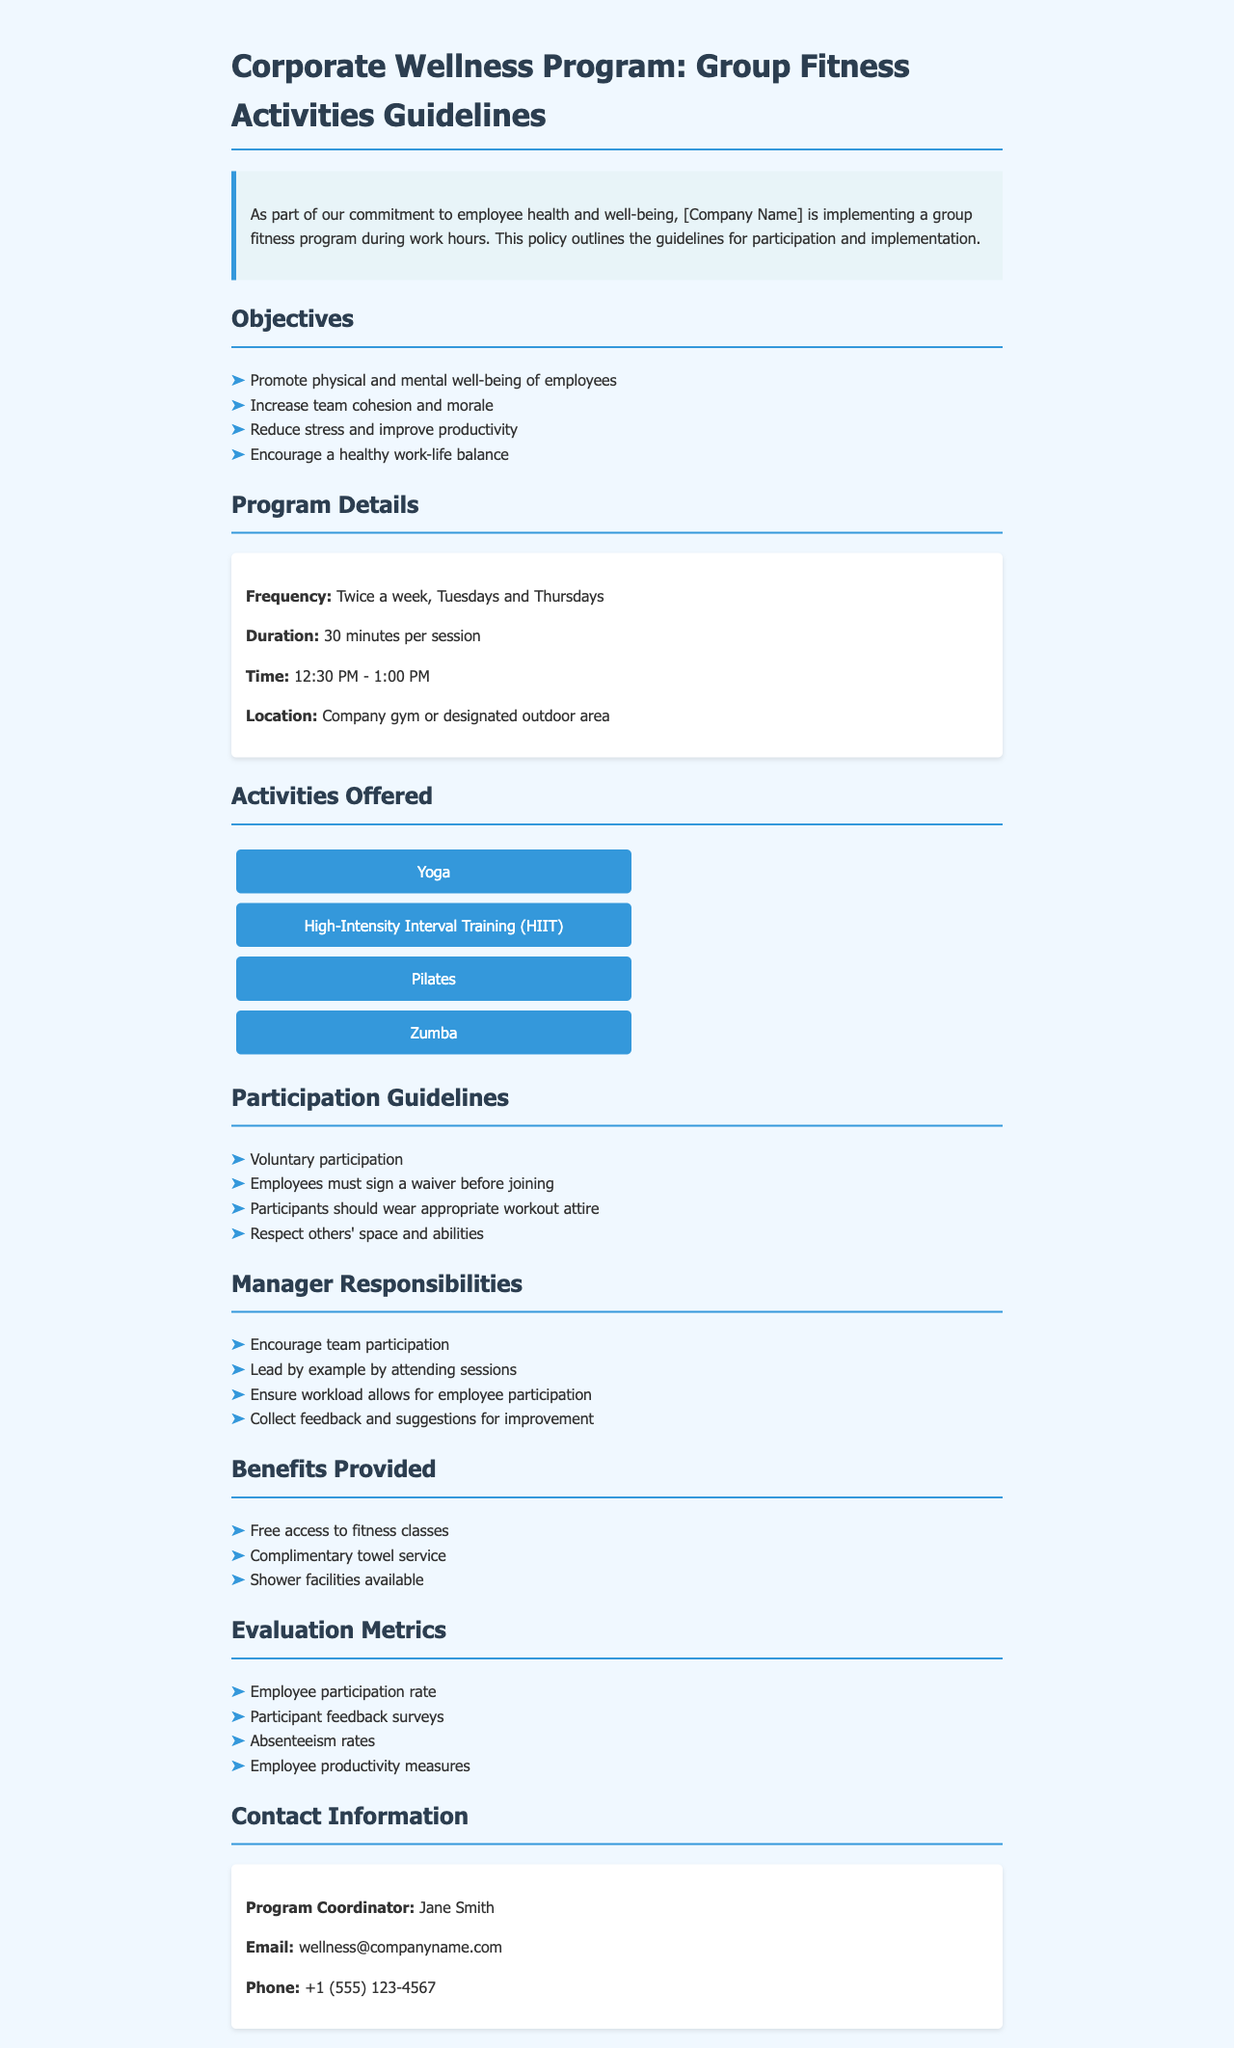What are the group fitness activity days? The document states that group fitness activities will take place twice a week on Tuesdays and Thursdays.
Answer: Tuesdays and Thursdays What is the duration of each fitness session? The document specifies that each session lasts for 30 minutes.
Answer: 30 minutes Who is the program coordinator? The document lists Jane Smith as the program coordinator.
Answer: Jane Smith What is required from employees before joining the fitness activities? The document mentions that employees must sign a waiver before participating in the activities.
Answer: Sign a waiver What time do the fitness sessions begin? According to the document, the fitness sessions start at 12:30 PM.
Answer: 12:30 PM Why should managers encourage participation? The document outlines that managers should encourage team participation to promote well-being and cohesion among employees.
Answer: Promote well-being and cohesion What facilities are available for employees after workouts? The document mentions that shower facilities are available for employees post-workout.
Answer: Shower facilities How will employee participation be evaluated? The document states that employee participation will be evaluated through participation rates and feedback surveys.
Answer: Participation rates and feedback surveys What activities are offered in the program? The document lists Yoga, High-Intensity Interval Training (HIIT), Pilates, and Zumba as the offered activities.
Answer: Yoga, HIIT, Pilates, Zumba 